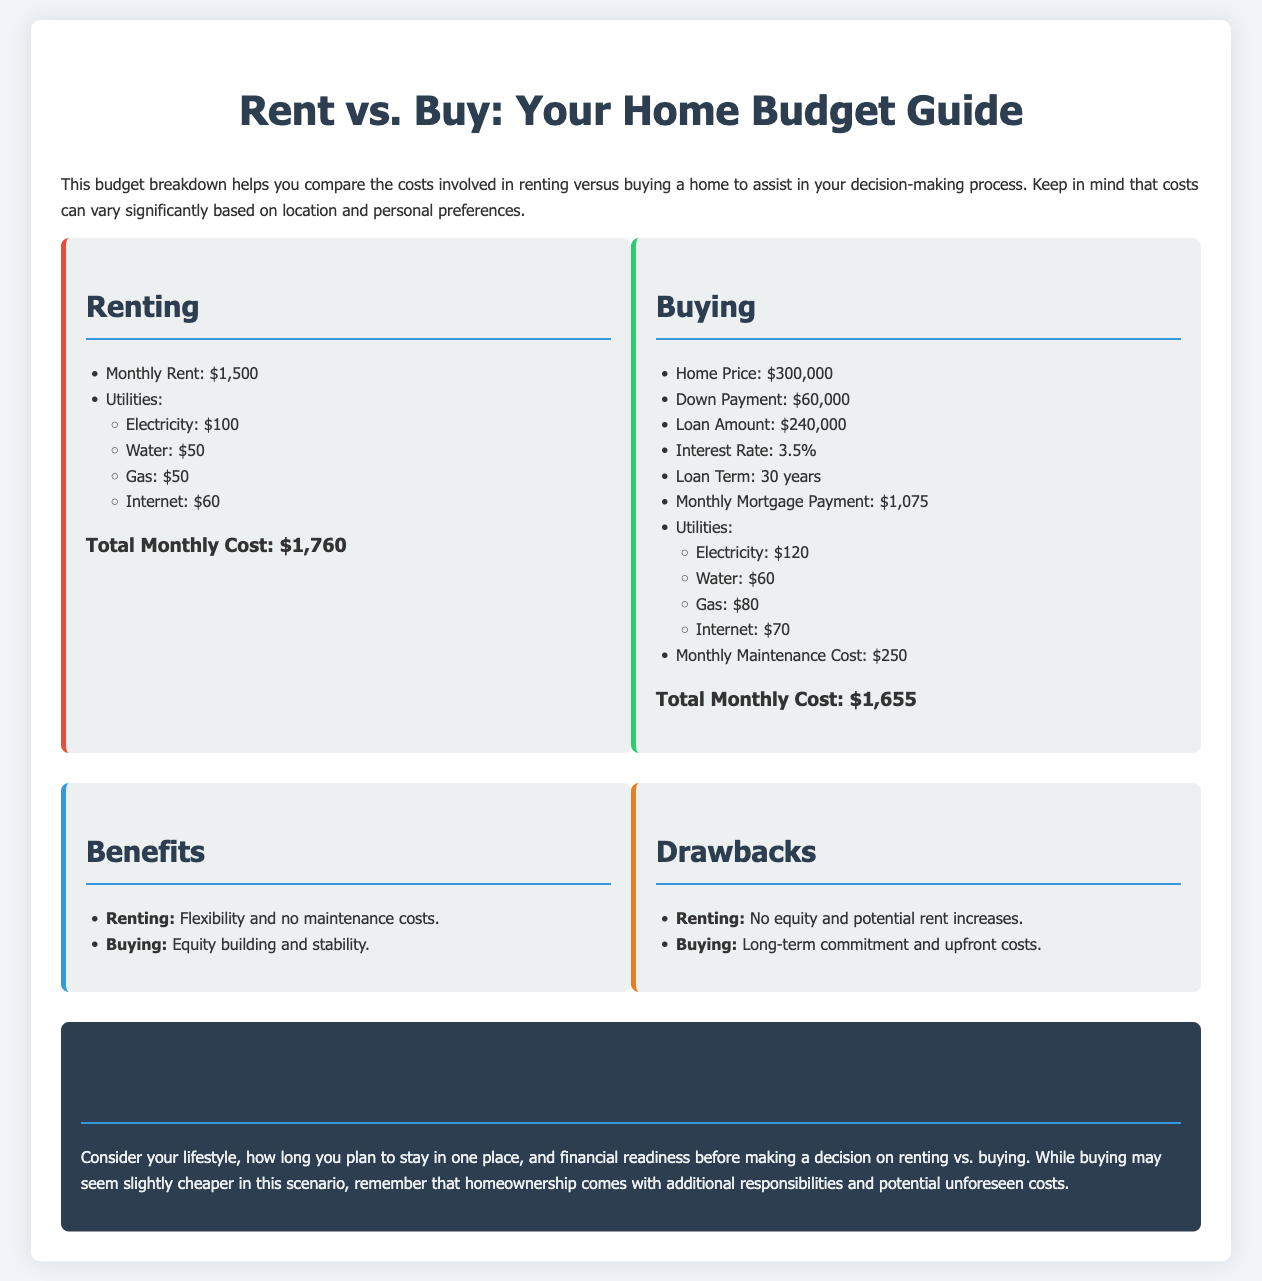what is the monthly rent? The monthly rent is explicitly listed as $1,500 in the document.
Answer: $1,500 what is the total monthly cost of renting? The total monthly cost of renting includes the rent and utilities, which adds up to $1,760.
Answer: $1,760 what is the home price when buying? The home price when buying is stated as $300,000 in the document.
Answer: $300,000 what is the monthly mortgage payment? The document indicates that the monthly mortgage payment is $1,075.
Answer: $1,075 what are the utilities costs when buying? The utilities costs when buying include electricity, water, gas, and internet, which total $330.
Answer: $330 what is the total monthly cost of buying? The total monthly cost of buying, including mortgage and utilities, is $1,655.
Answer: $1,655 what is one benefit of renting mentioned? The document states that a benefit of renting is flexibility.
Answer: flexibility what is one drawback of buying mentioned? One drawback of buying mentioned is long-term commitment.
Answer: long-term commitment what is the monthly maintenance cost when buying? The document specifies that the monthly maintenance cost when buying is $250.
Answer: $250 